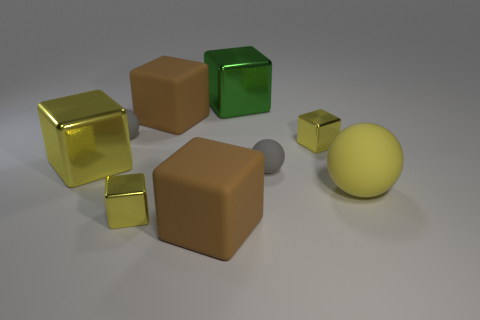Subtract all cyan balls. How many yellow cubes are left? 3 Subtract all brown blocks. How many blocks are left? 4 Subtract all large brown matte blocks. How many blocks are left? 4 Subtract 2 blocks. How many blocks are left? 4 Subtract all gray cubes. Subtract all green cylinders. How many cubes are left? 6 Add 1 large cyan cylinders. How many objects exist? 10 Subtract all spheres. How many objects are left? 6 Add 4 small yellow cubes. How many small yellow cubes are left? 6 Add 1 small yellow cubes. How many small yellow cubes exist? 3 Subtract 0 red cylinders. How many objects are left? 9 